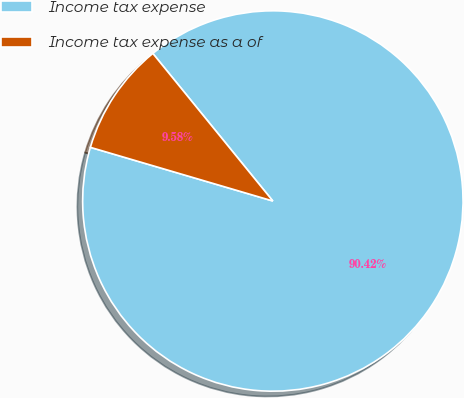Convert chart to OTSL. <chart><loc_0><loc_0><loc_500><loc_500><pie_chart><fcel>Income tax expense<fcel>Income tax expense as a of<nl><fcel>90.42%<fcel>9.58%<nl></chart> 